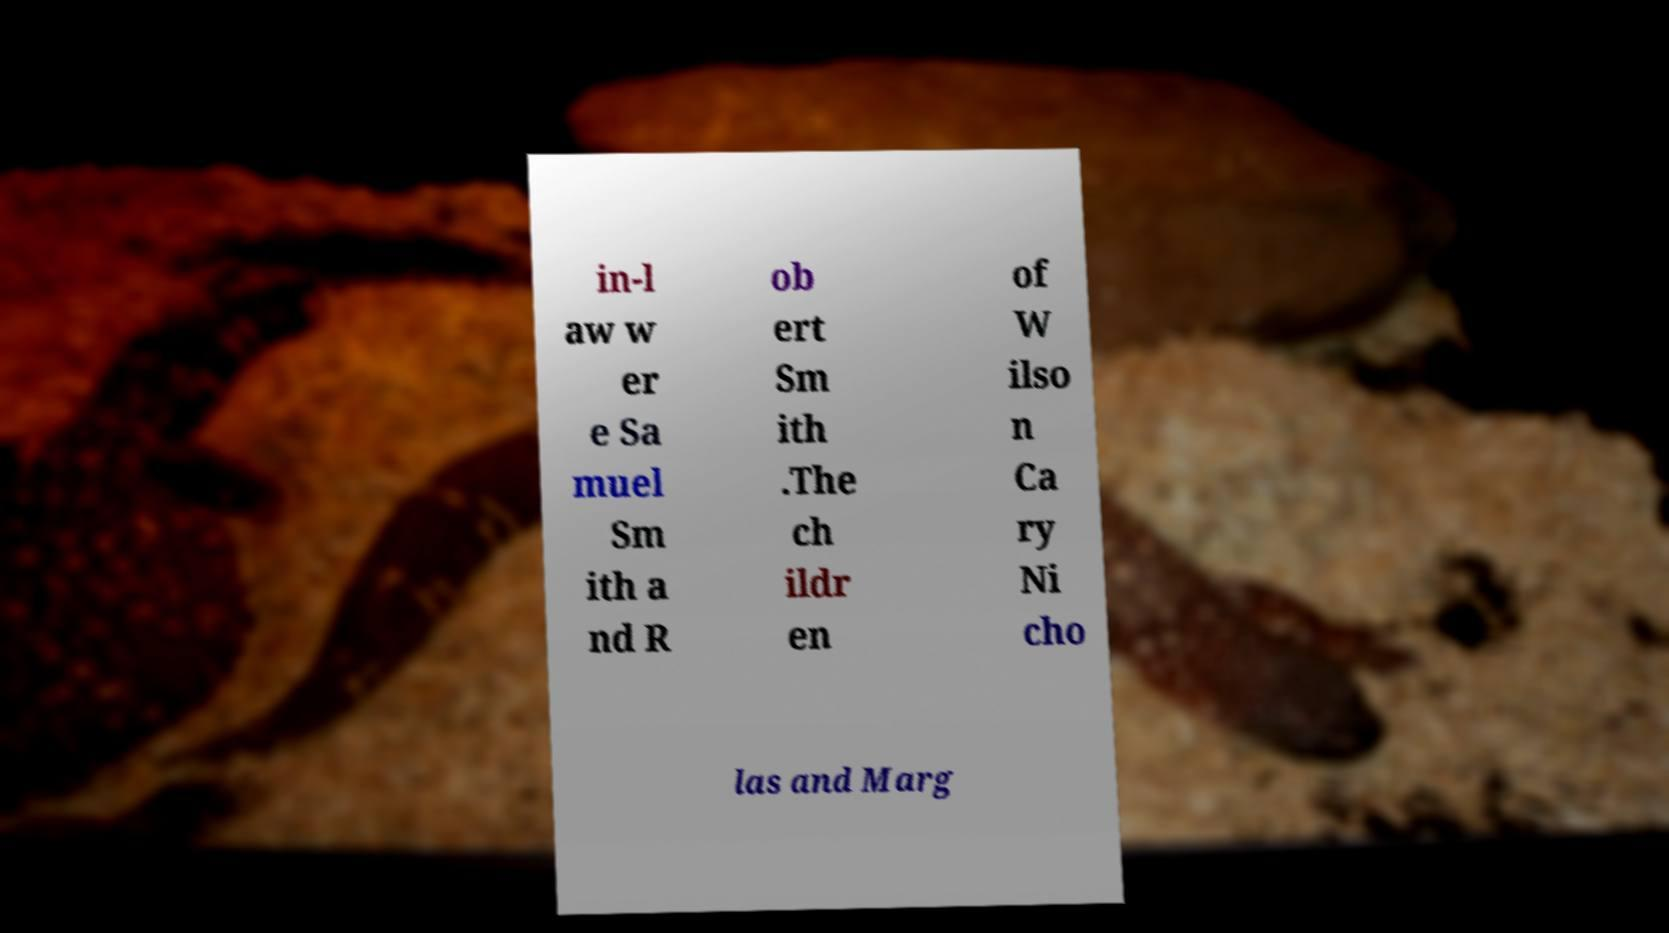Could you assist in decoding the text presented in this image and type it out clearly? in-l aw w er e Sa muel Sm ith a nd R ob ert Sm ith .The ch ildr en of W ilso n Ca ry Ni cho las and Marg 